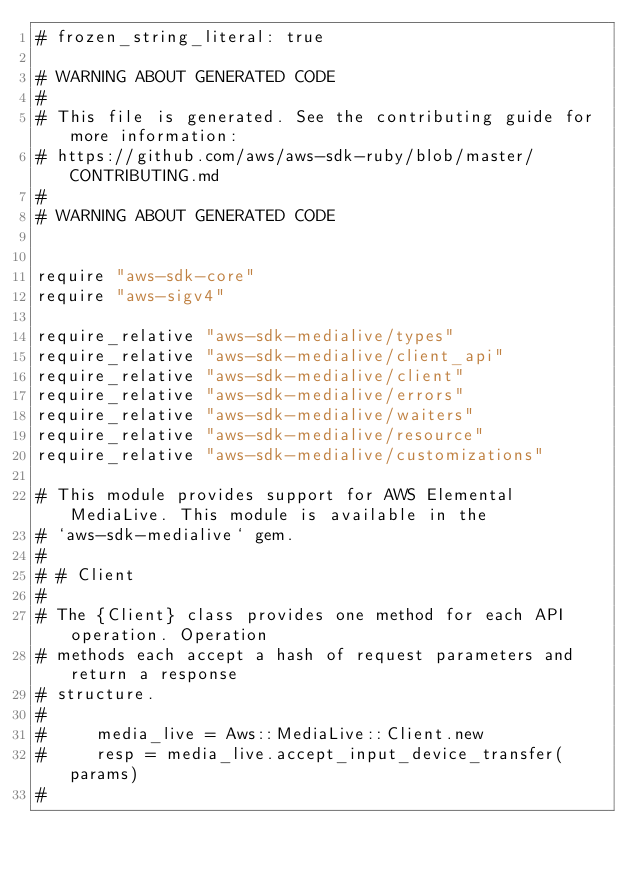Convert code to text. <code><loc_0><loc_0><loc_500><loc_500><_Crystal_># frozen_string_literal: true

# WARNING ABOUT GENERATED CODE
#
# This file is generated. See the contributing guide for more information:
# https://github.com/aws/aws-sdk-ruby/blob/master/CONTRIBUTING.md
#
# WARNING ABOUT GENERATED CODE


require "aws-sdk-core"
require "aws-sigv4"

require_relative "aws-sdk-medialive/types"
require_relative "aws-sdk-medialive/client_api"
require_relative "aws-sdk-medialive/client"
require_relative "aws-sdk-medialive/errors"
require_relative "aws-sdk-medialive/waiters"
require_relative "aws-sdk-medialive/resource"
require_relative "aws-sdk-medialive/customizations"

# This module provides support for AWS Elemental MediaLive. This module is available in the
# `aws-sdk-medialive` gem.
#
# # Client
#
# The {Client} class provides one method for each API operation. Operation
# methods each accept a hash of request parameters and return a response
# structure.
#
#     media_live = Aws::MediaLive::Client.new
#     resp = media_live.accept_input_device_transfer(params)
#</code> 